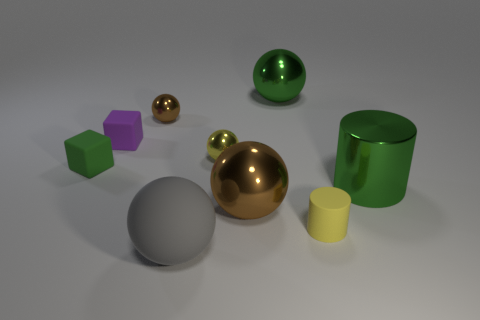Are there any spheres of the same color as the big rubber thing?
Keep it short and to the point. No. Is the material of the brown object that is on the left side of the gray thing the same as the block that is in front of the purple matte cube?
Provide a succinct answer. No. The large cylinder is what color?
Offer a very short reply. Green. How big is the purple object behind the large metallic sphere that is in front of the big green metallic object that is left of the yellow matte thing?
Your response must be concise. Small. What number of other objects are the same size as the purple matte object?
Keep it short and to the point. 4. How many big gray cylinders are the same material as the tiny yellow cylinder?
Keep it short and to the point. 0. The yellow object in front of the yellow metal thing has what shape?
Give a very brief answer. Cylinder. Is the tiny brown ball made of the same material as the large green thing in front of the tiny purple rubber block?
Offer a very short reply. Yes. Are any large green metal spheres visible?
Make the answer very short. Yes. Is there a matte ball behind the small rubber thing that is to the right of the small metal sphere that is behind the small yellow shiny ball?
Offer a terse response. No. 